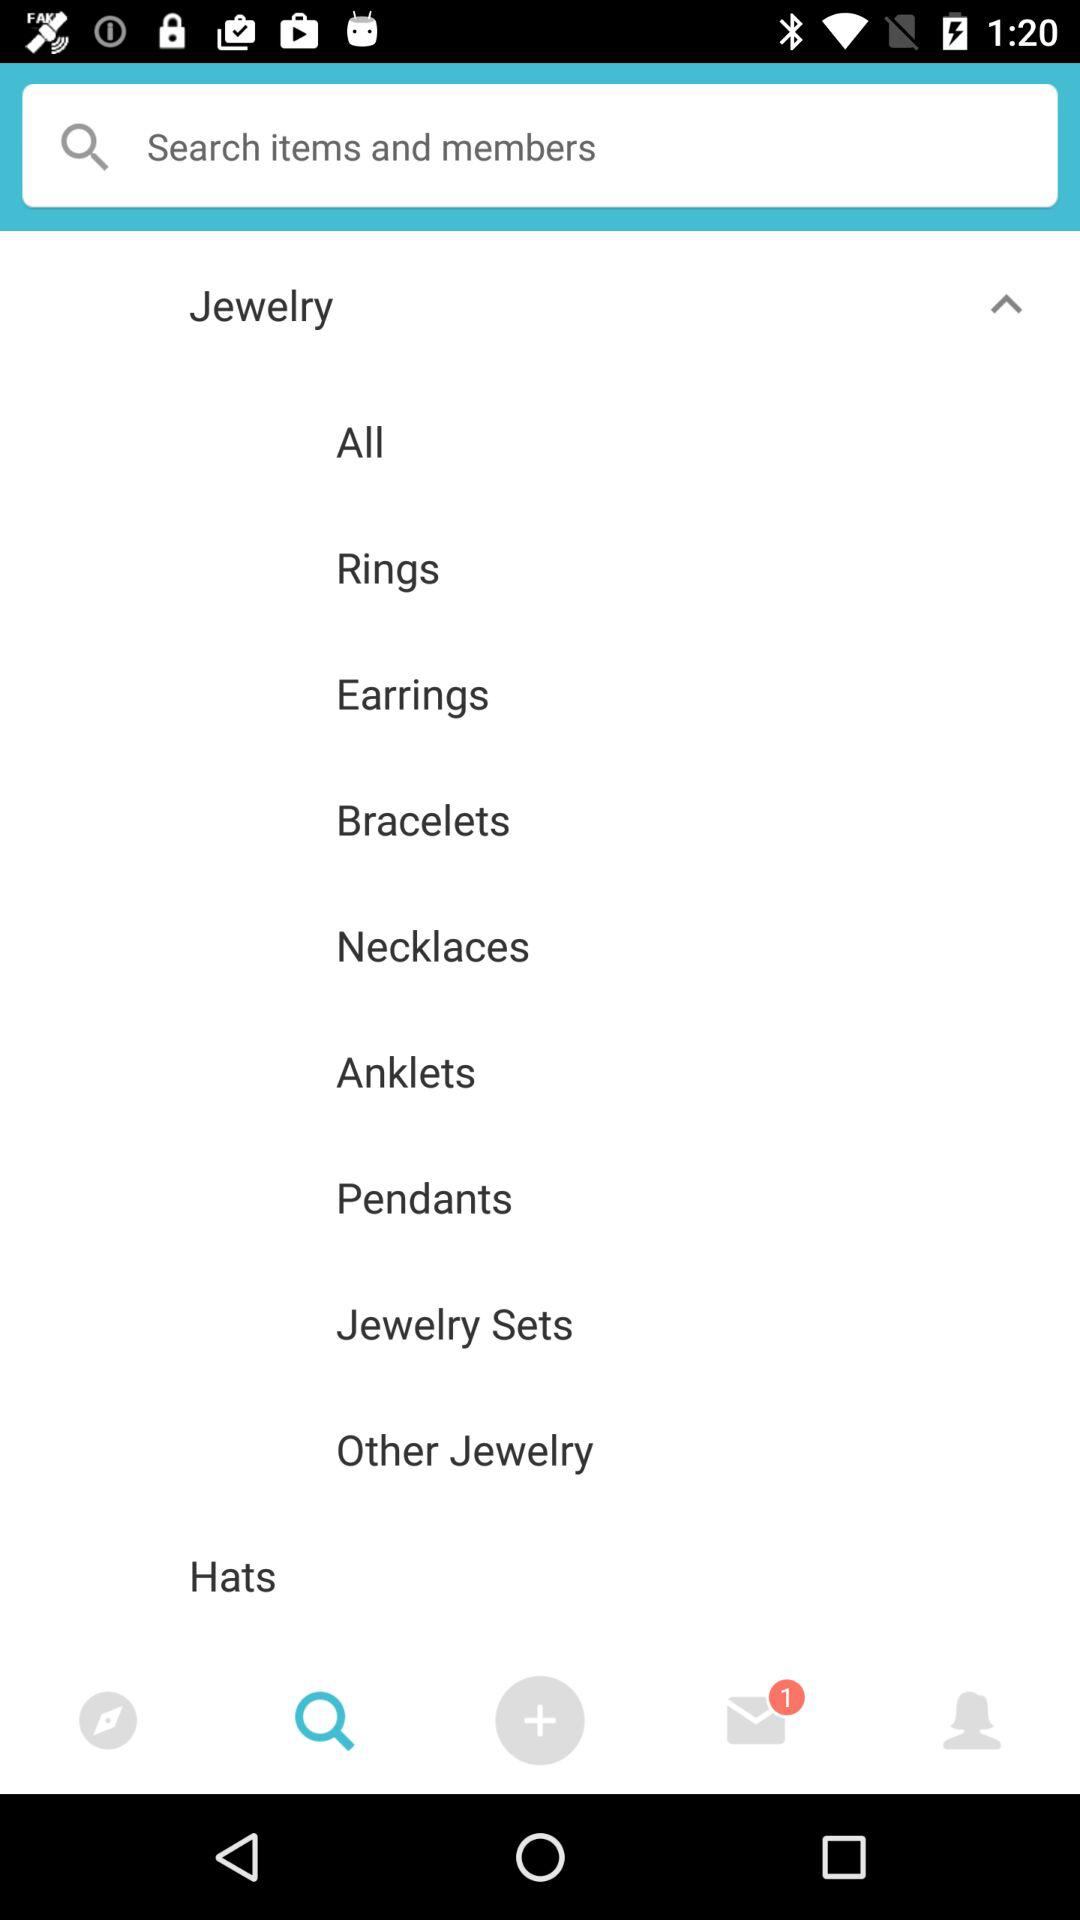Which tab is selected? The selected tab is "Search". 